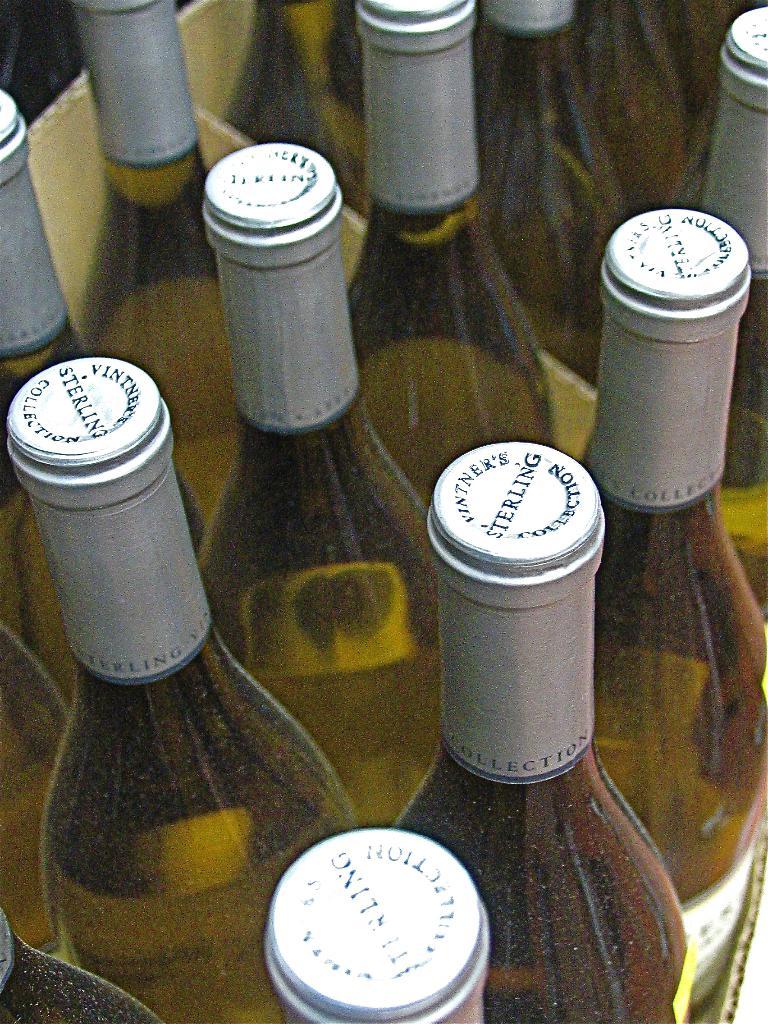What is the brand of the wine?
Give a very brief answer. Sterling. What type of wine?
Make the answer very short. Sterling. 